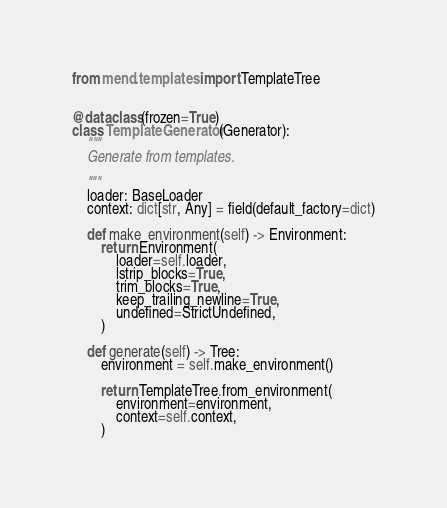<code> <loc_0><loc_0><loc_500><loc_500><_Python_>from mend.templates import TemplateTree


@dataclass(frozen=True)
class TemplateGenerator(Generator):
    """
    Generate from templates.

    """
    loader: BaseLoader
    context: dict[str, Any] = field(default_factory=dict)

    def make_environment(self) -> Environment:
        return Environment(
            loader=self.loader,
            lstrip_blocks=True,
            trim_blocks=True,
            keep_trailing_newline=True,
            undefined=StrictUndefined,
        )

    def generate(self) -> Tree:
        environment = self.make_environment()

        return TemplateTree.from_environment(
            environment=environment,
            context=self.context,
        )
</code> 